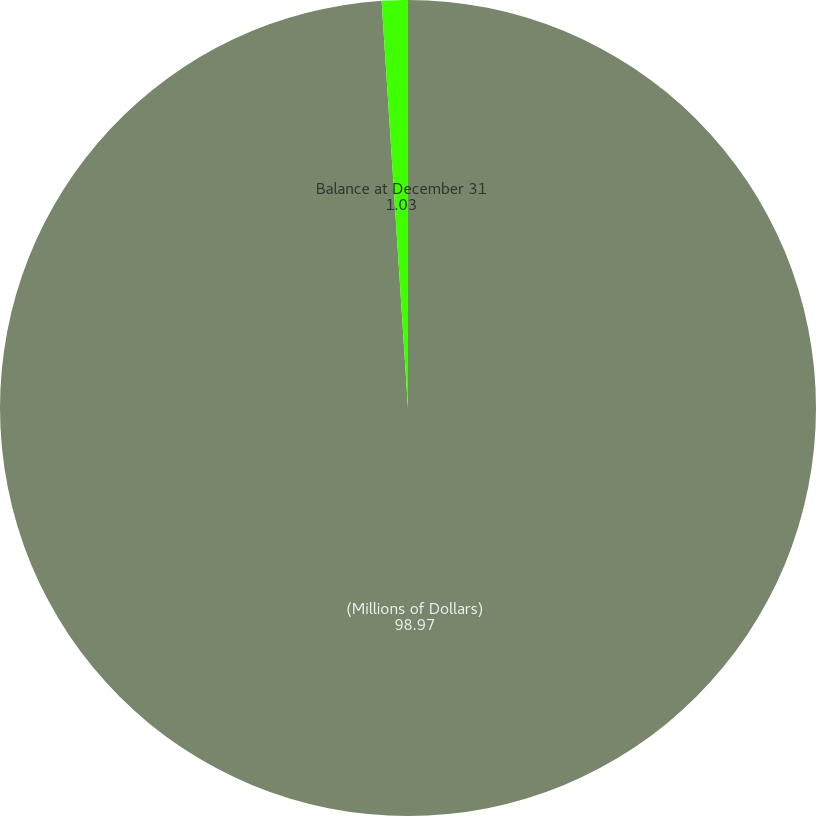<chart> <loc_0><loc_0><loc_500><loc_500><pie_chart><fcel>(Millions of Dollars)<fcel>Balance at December 31<nl><fcel>98.97%<fcel>1.03%<nl></chart> 